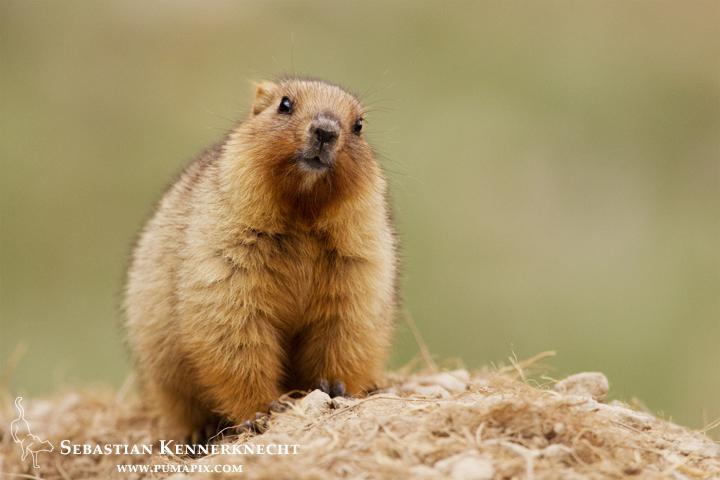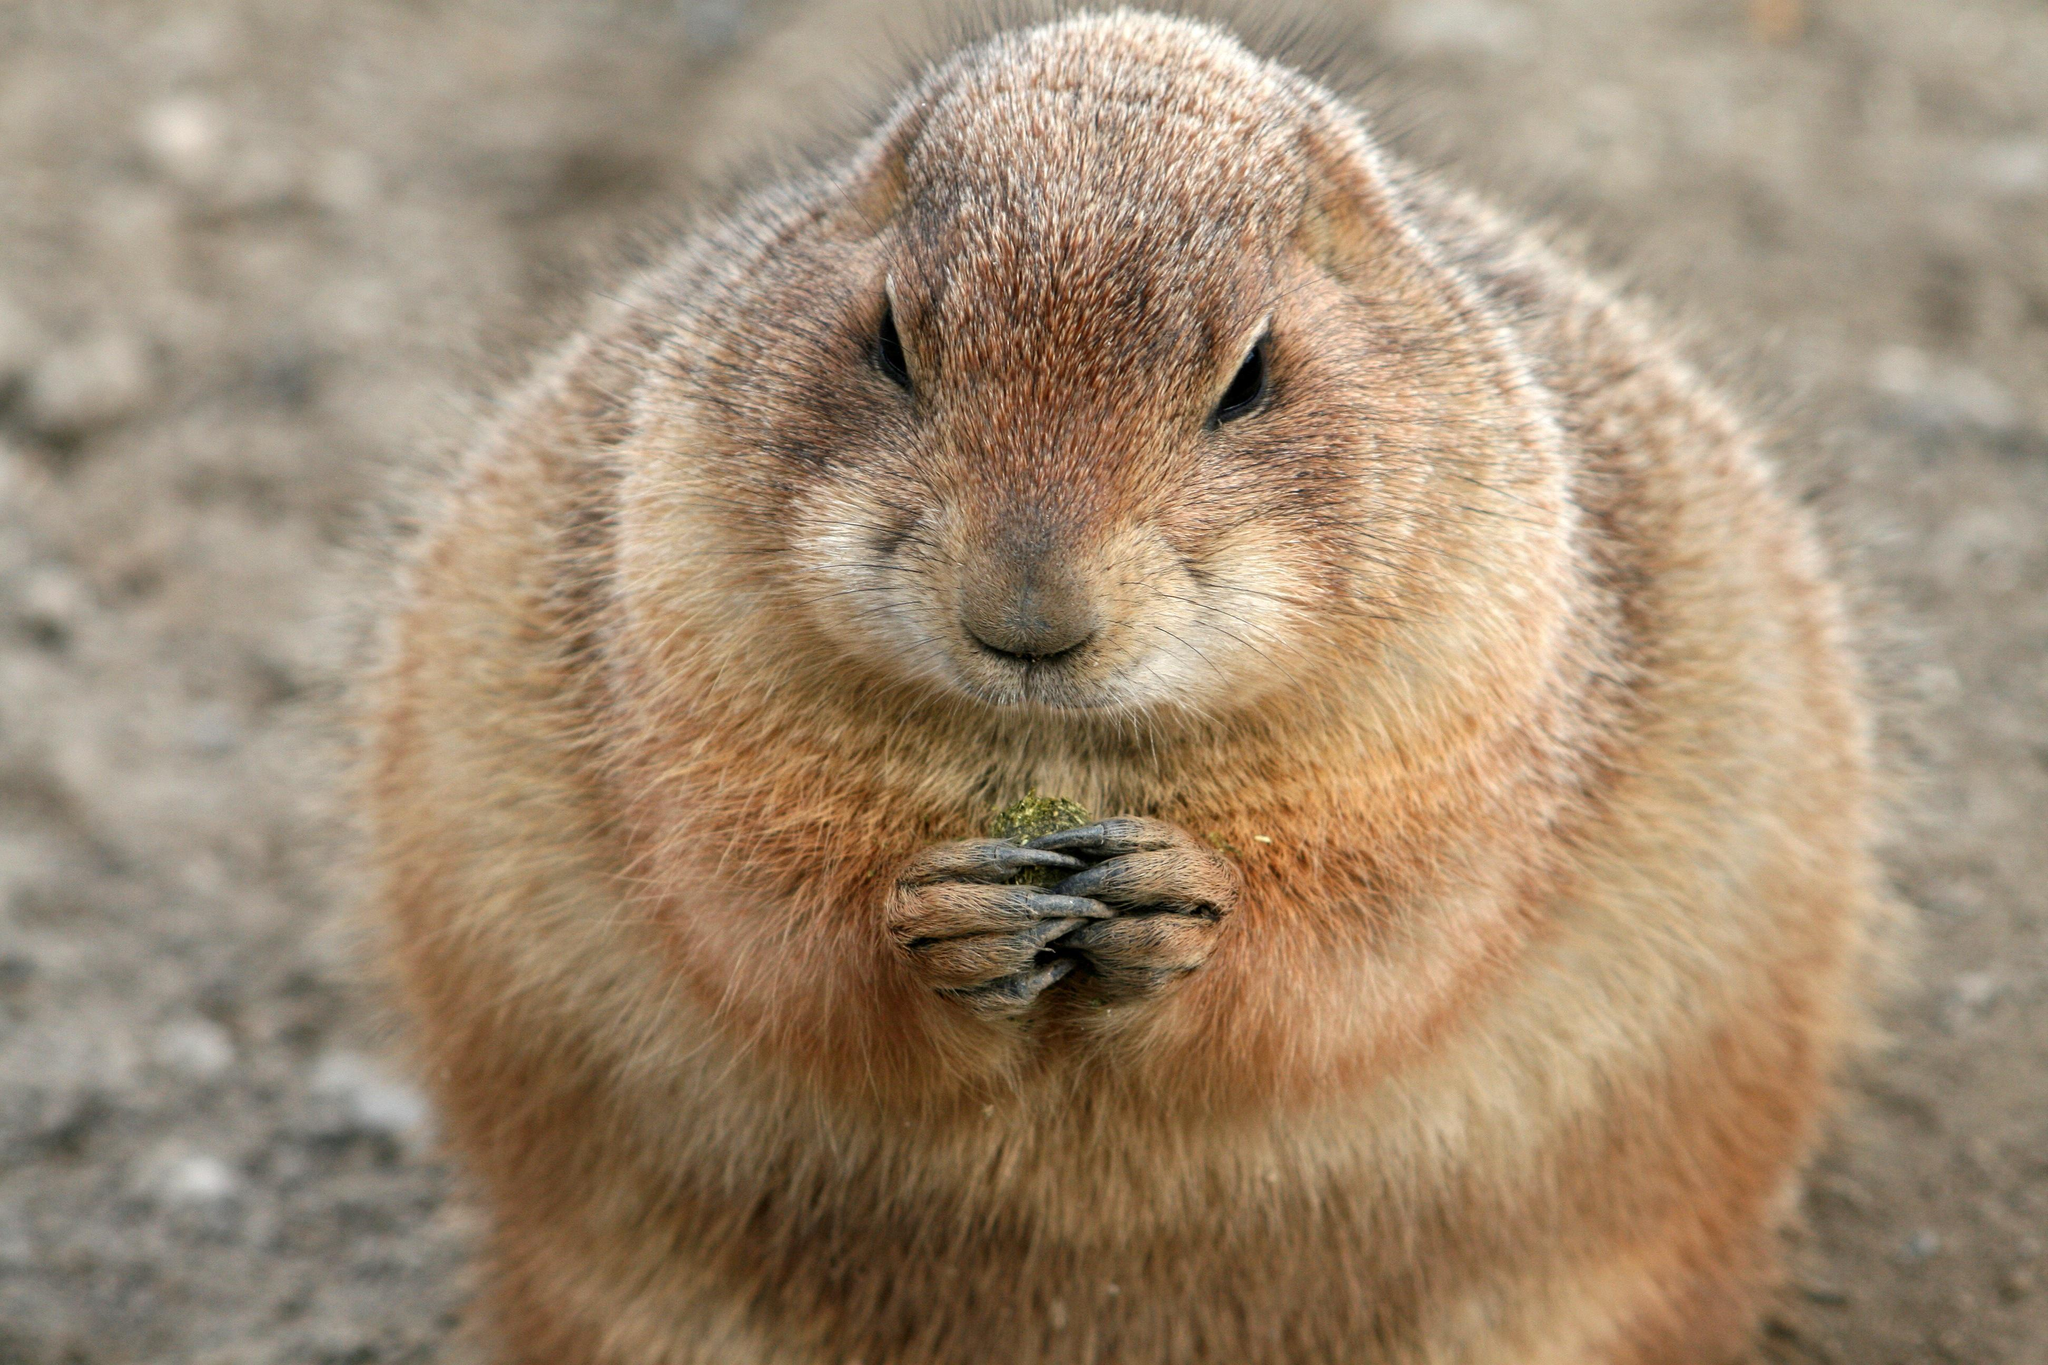The first image is the image on the left, the second image is the image on the right. Considering the images on both sides, is "There are two brown furry little animals outside." valid? Answer yes or no. Yes. The first image is the image on the left, the second image is the image on the right. For the images displayed, is the sentence "Two groundhogs are standing very close together." factually correct? Answer yes or no. No. 